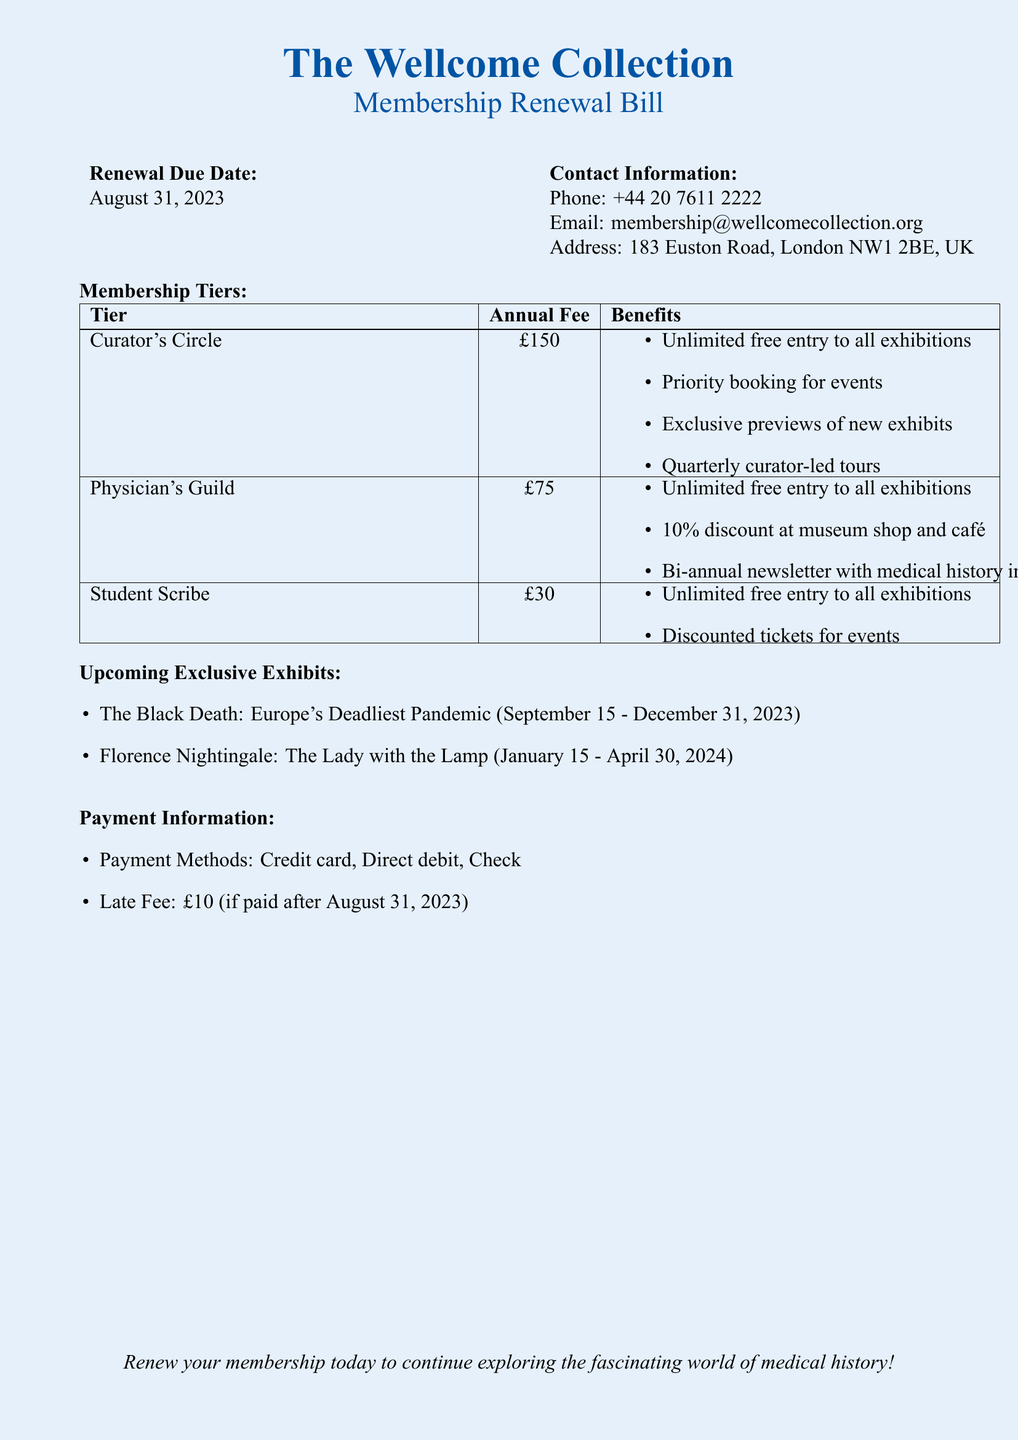What is the renewal due date? The renewal due date is stated explicitly in the document.
Answer: August 31, 2023 What is the annual fee for the Curator's Circle? The annual fee for the Curator's Circle is listed in the membership tiers section.
Answer: £150 What benefit do members of the Physician's Guild receive at the museum shop? The benefit at the museum shop is detailed under the Physician's Guild benefits.
Answer: 10% discount What is unique about the upcoming exhibit starting on September 15, 2023? It is specified in the document as the theme of the exhibit.
Answer: The Black Death: Europe's Deadliest Pandemic What is the late fee if payment is made after August 31, 2023? The late fee amount is explicitly mentioned in the payment information section.
Answer: £10 Which tier offers a quarterly curator-led tour? This tier is listed with its benefits in the membership tiers section.
Answer: Curator's Circle What payment methods are accepted? The document lists the available payment methods.
Answer: Credit card, Direct debit, Check Who can attend discounted tickets for events? This benefit is mentioned in the tier descriptions.
Answer: Student Scribe What is included in the bi-annual newsletter for the Physician's Guild? The content of the newsletter is described under the benefits for the Physician's Guild.
Answer: Medical history insights 